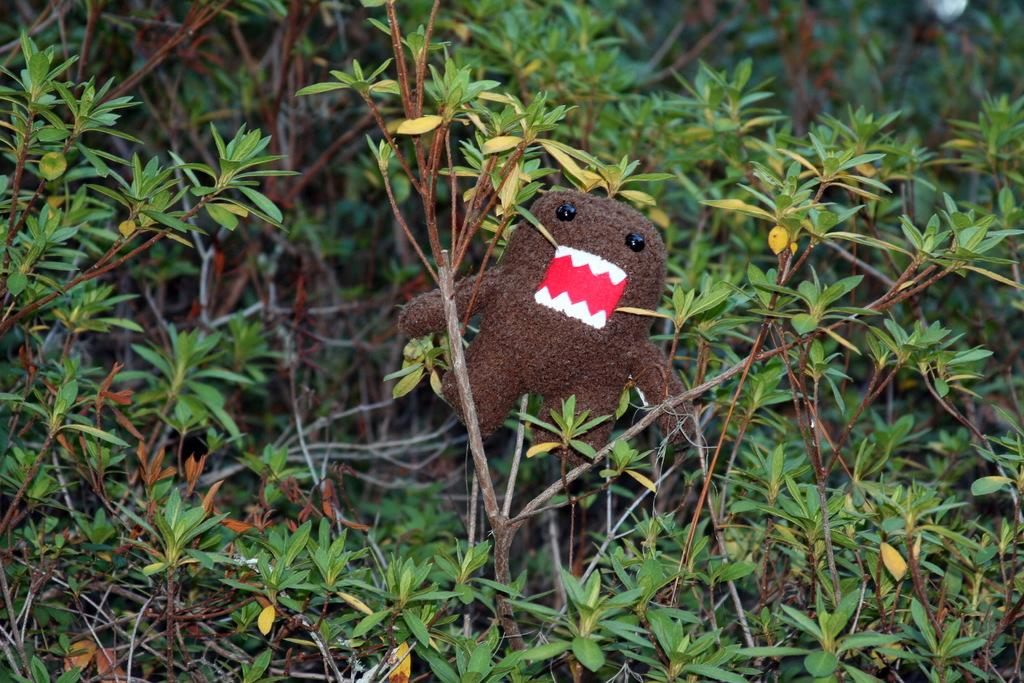What is the main subject in the middle of the image? There is a toy in the middle of the image. What can be seen around the toy? There are plants surrounding the toy. What type of roof can be seen on the toy in the image? There is no roof present on the toy in the image. What rhythm is the toy playing in the image? The toy does not play any rhythm in the image; it is a stationary object. 